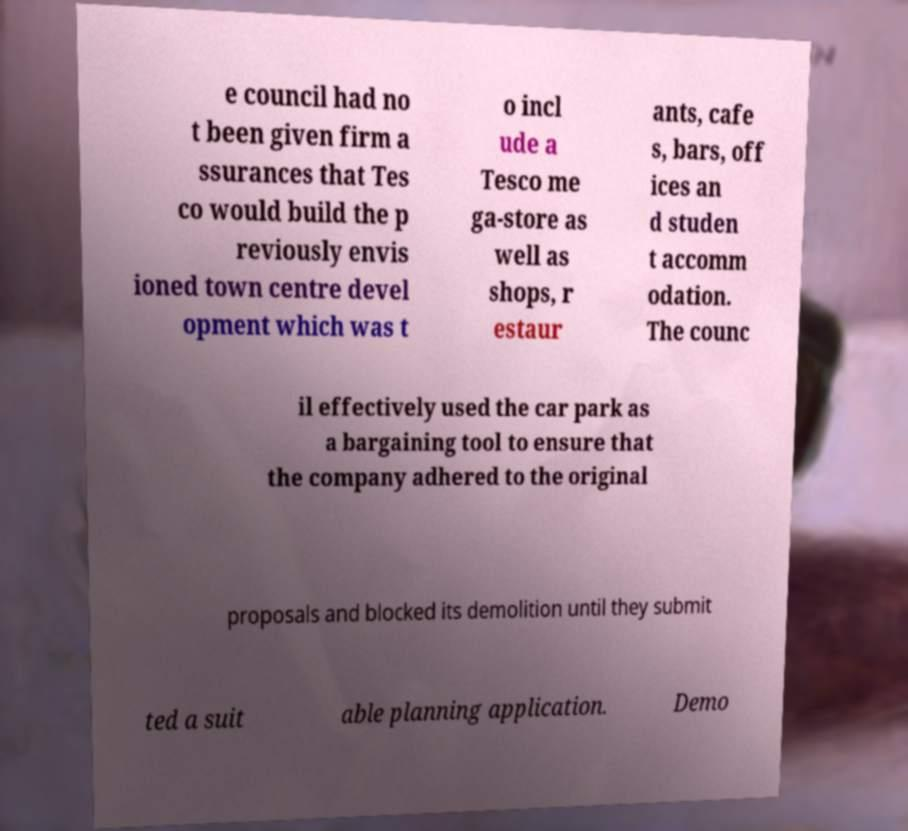There's text embedded in this image that I need extracted. Can you transcribe it verbatim? e council had no t been given firm a ssurances that Tes co would build the p reviously envis ioned town centre devel opment which was t o incl ude a Tesco me ga-store as well as shops, r estaur ants, cafe s, bars, off ices an d studen t accomm odation. The counc il effectively used the car park as a bargaining tool to ensure that the company adhered to the original proposals and blocked its demolition until they submit ted a suit able planning application. Demo 